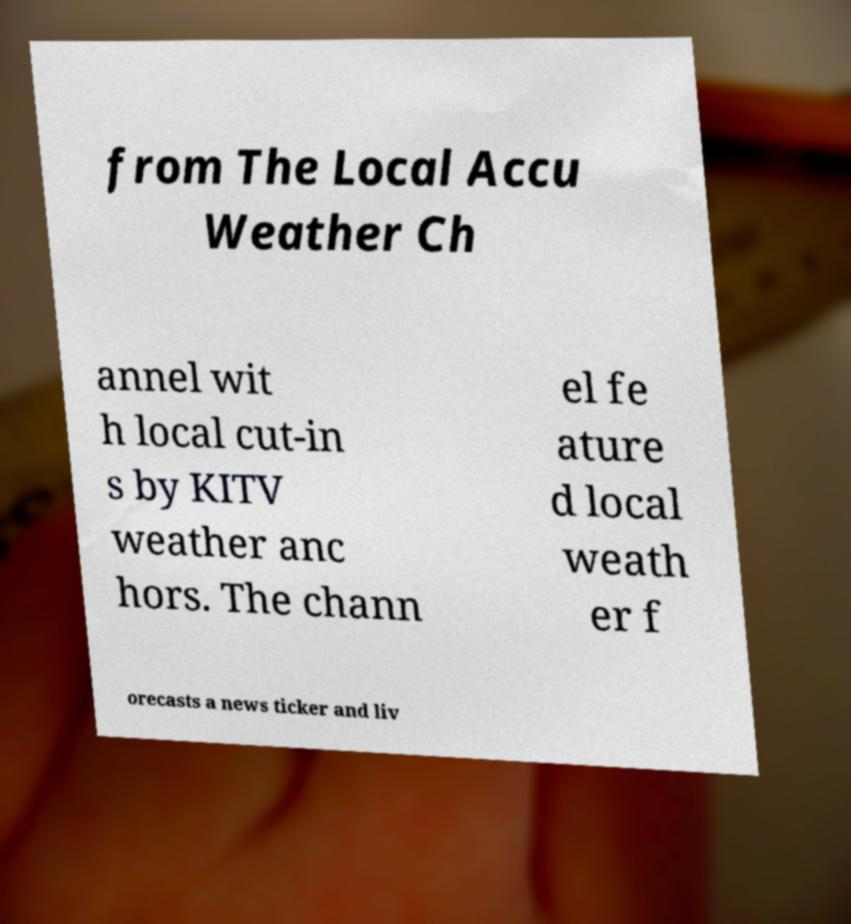Could you assist in decoding the text presented in this image and type it out clearly? from The Local Accu Weather Ch annel wit h local cut-in s by KITV weather anc hors. The chann el fe ature d local weath er f orecasts a news ticker and liv 